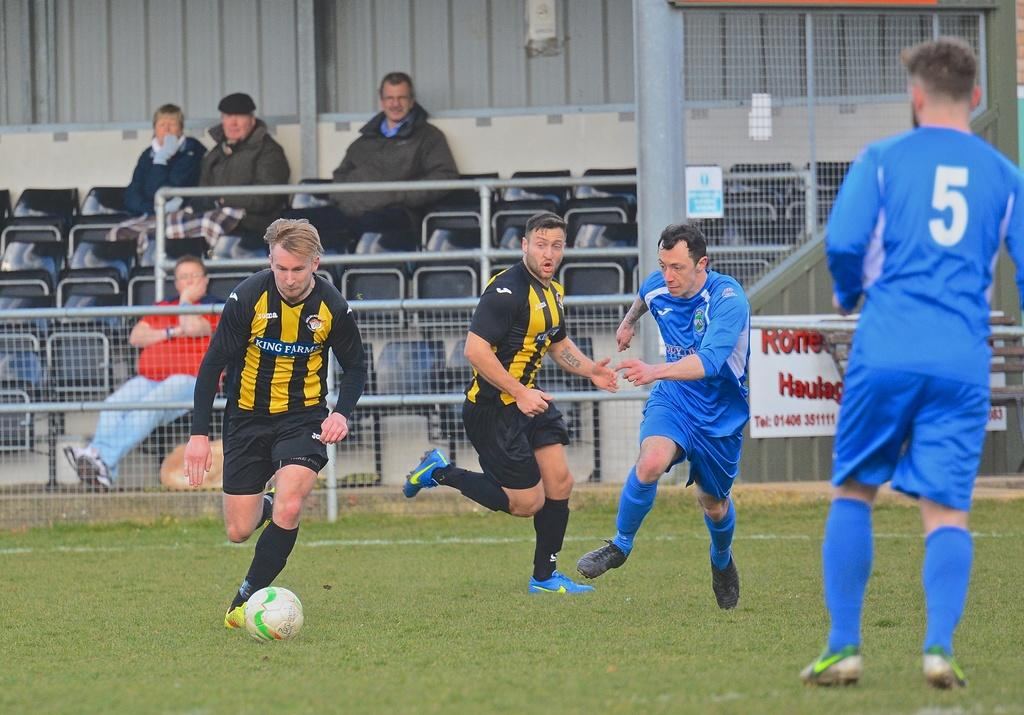<image>
Write a terse but informative summary of the picture. Athletes on a field include a man whose blue shirt has the number five. 